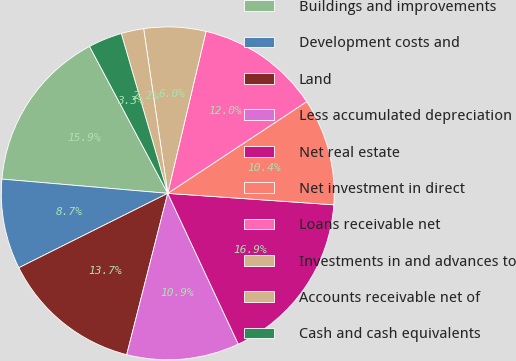Convert chart. <chart><loc_0><loc_0><loc_500><loc_500><pie_chart><fcel>Buildings and improvements<fcel>Development costs and<fcel>Land<fcel>Less accumulated depreciation<fcel>Net real estate<fcel>Net investment in direct<fcel>Loans receivable net<fcel>Investments in and advances to<fcel>Accounts receivable net of<fcel>Cash and cash equivalents<nl><fcel>15.85%<fcel>8.74%<fcel>13.66%<fcel>10.93%<fcel>16.94%<fcel>10.38%<fcel>12.02%<fcel>6.01%<fcel>2.19%<fcel>3.28%<nl></chart> 